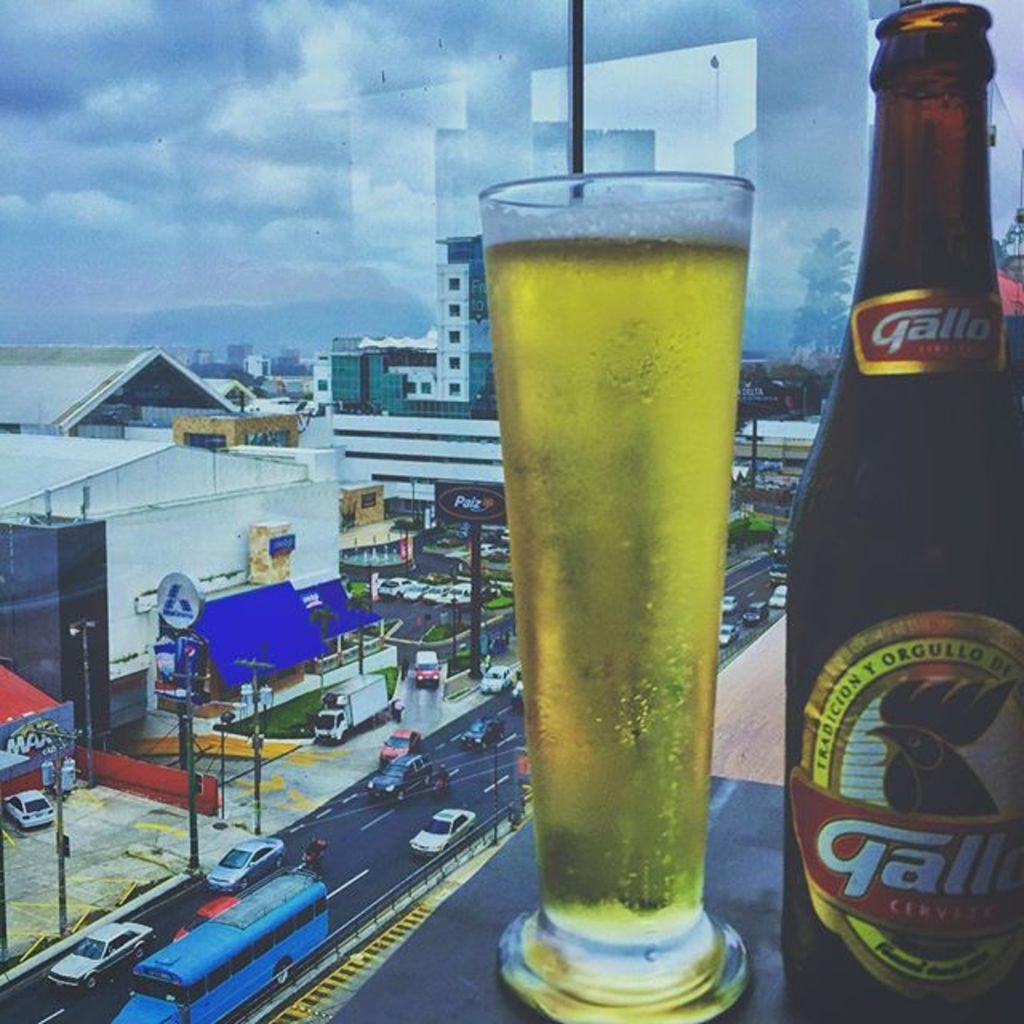Could you give a brief overview of what you see in this image? In this picture, we can see a glass with liquid in it, bottle, buildings, posters, poles, trees, grass and the sky with clouds. 